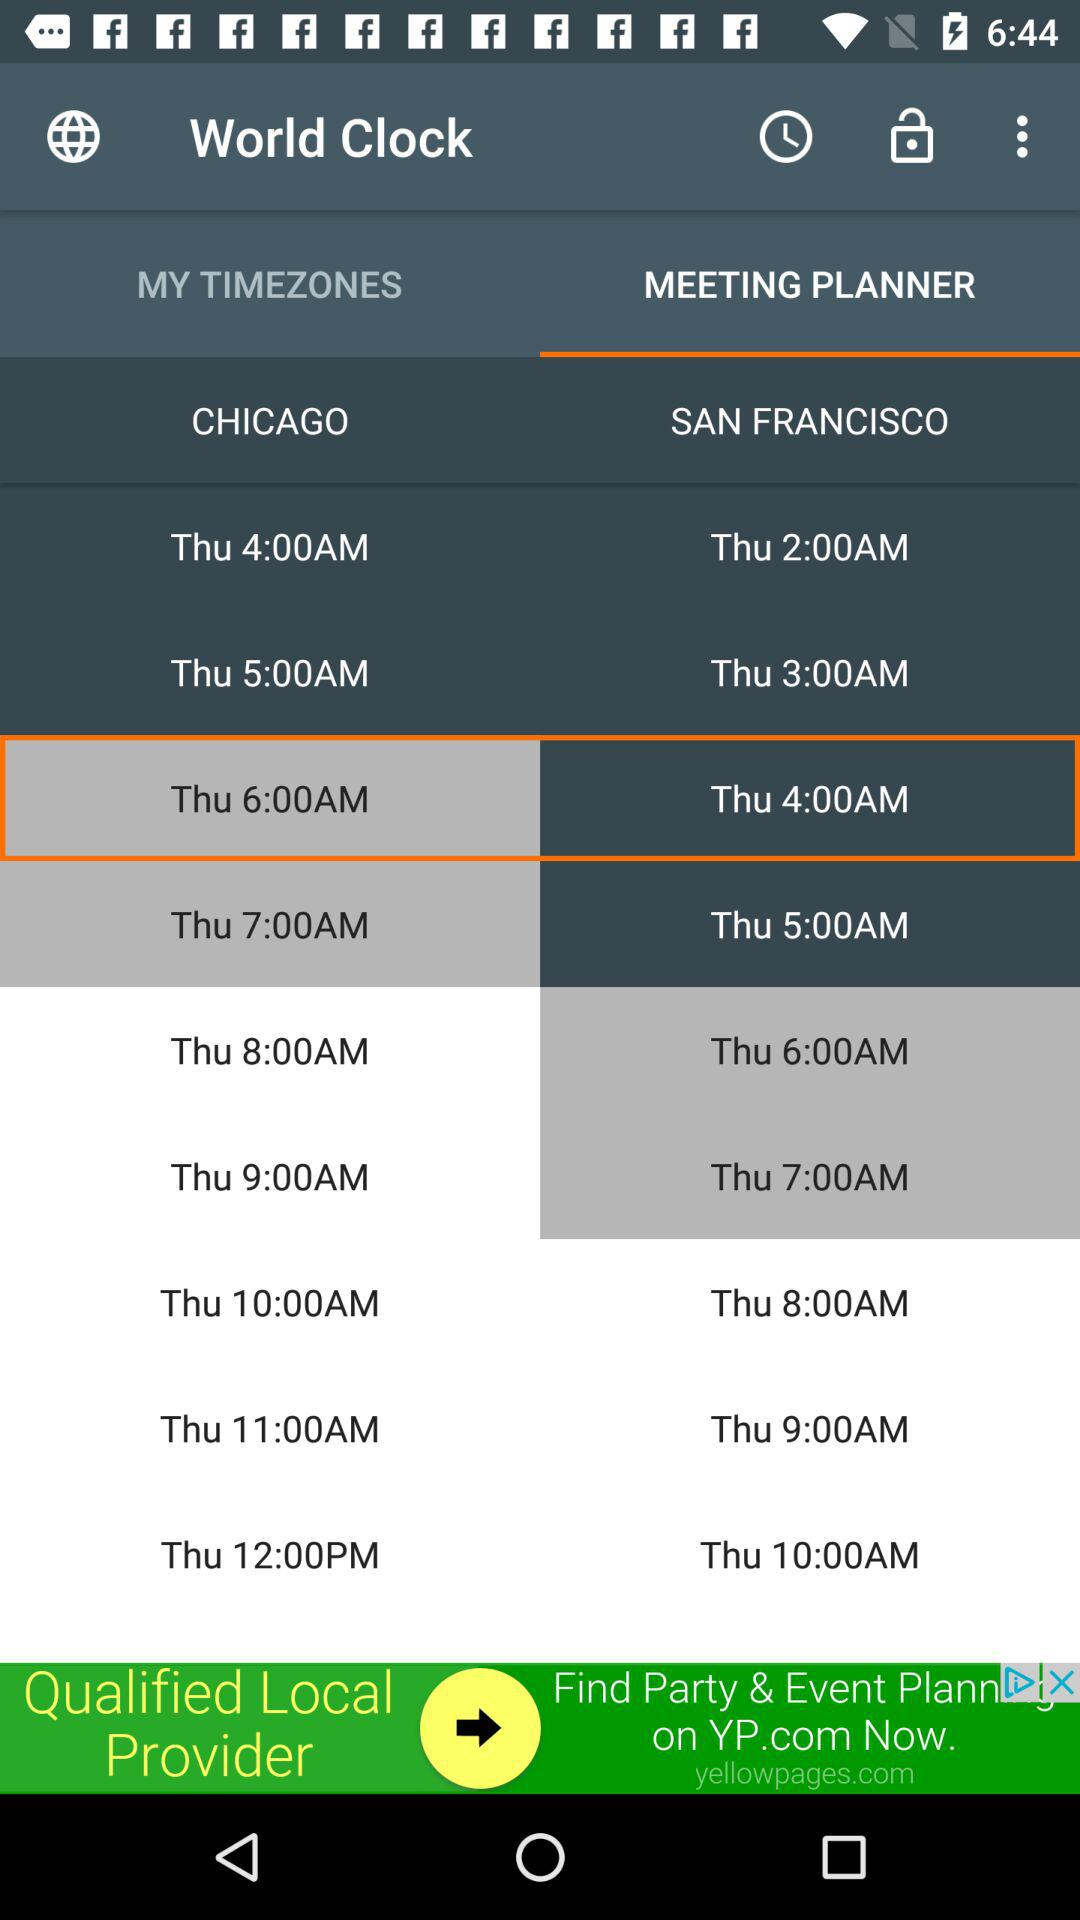What is the application name? The application name is "World Clock". 